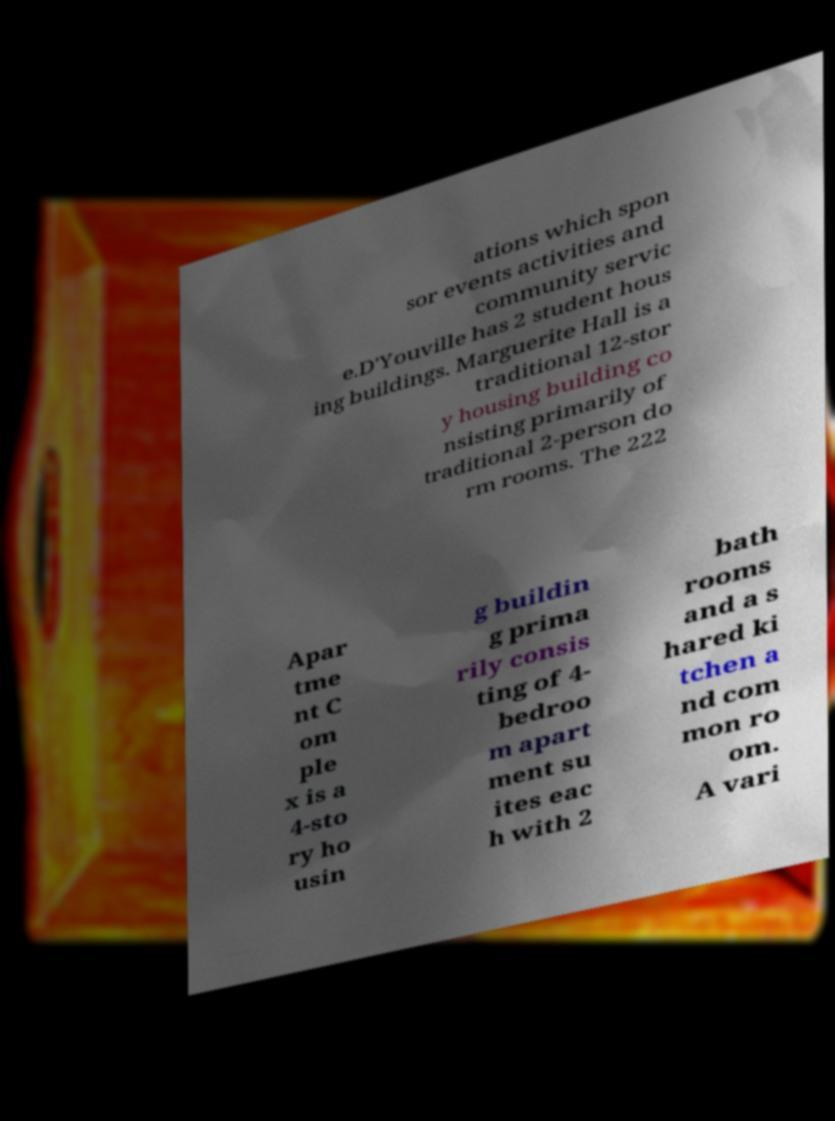I need the written content from this picture converted into text. Can you do that? ations which spon sor events activities and community servic e.D'Youville has 2 student hous ing buildings. Marguerite Hall is a traditional 12-stor y housing building co nsisting primarily of traditional 2-person do rm rooms. The 222 Apar tme nt C om ple x is a 4-sto ry ho usin g buildin g prima rily consis ting of 4- bedroo m apart ment su ites eac h with 2 bath rooms and a s hared ki tchen a nd com mon ro om. A vari 